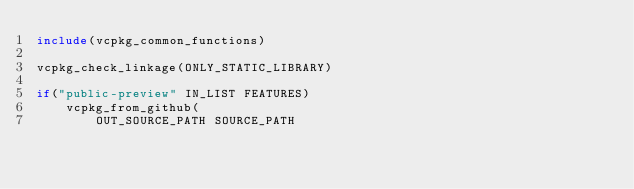<code> <loc_0><loc_0><loc_500><loc_500><_CMake_>include(vcpkg_common_functions)

vcpkg_check_linkage(ONLY_STATIC_LIBRARY)

if("public-preview" IN_LIST FEATURES)
    vcpkg_from_github(
        OUT_SOURCE_PATH SOURCE_PATH</code> 